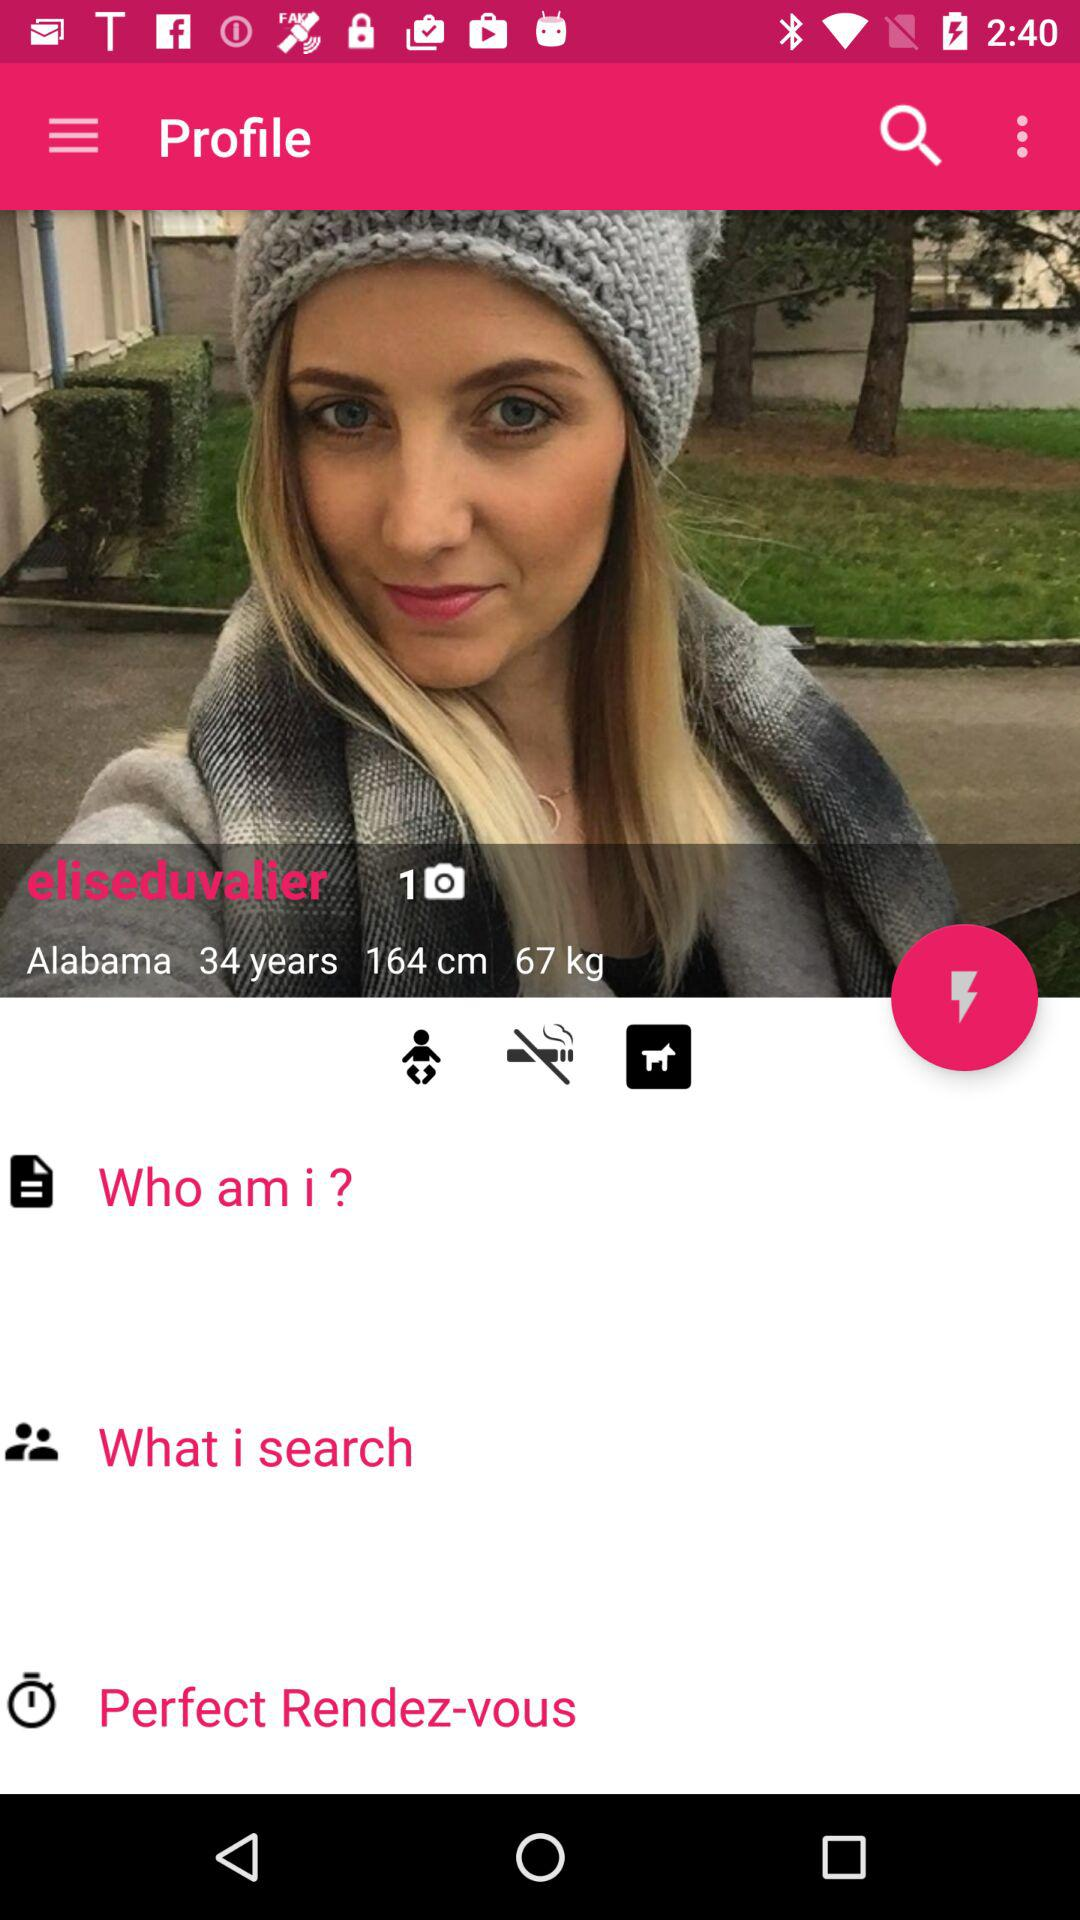Who is "eliseduvalier" searching for?
When the provided information is insufficient, respond with <no answer>. <no answer> 